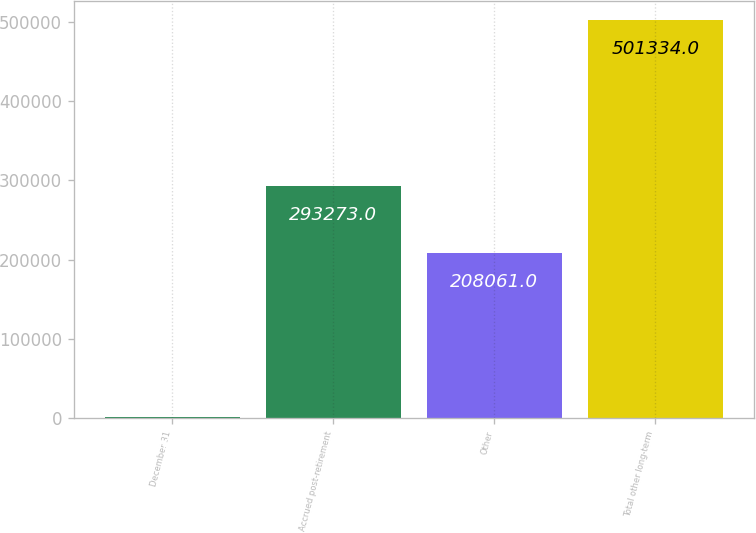<chart> <loc_0><loc_0><loc_500><loc_500><bar_chart><fcel>December 31<fcel>Accrued post-retirement<fcel>Other<fcel>Total other long-term<nl><fcel>2009<fcel>293273<fcel>208061<fcel>501334<nl></chart> 